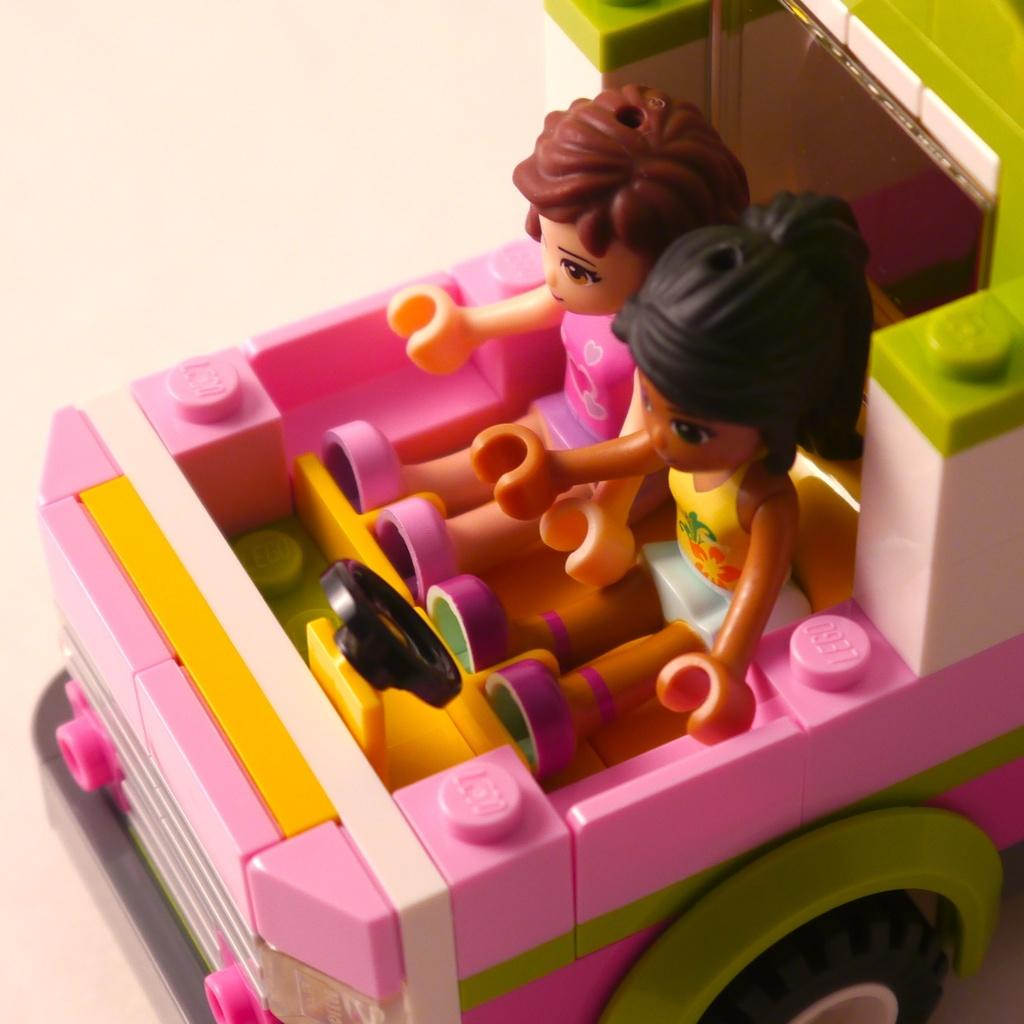What is the main subject of the image? The main subject of the image is a toy car. Are there any other objects or figures in the toy car? Yes, there are two dolls inside the toy car. What type of offer can be seen on the toy car in the image? There is no offer present on the toy car in the image. What color is the gold mitten that is being held by one of the dolls in the image? There is no mitten, gold or otherwise, present in the image. 